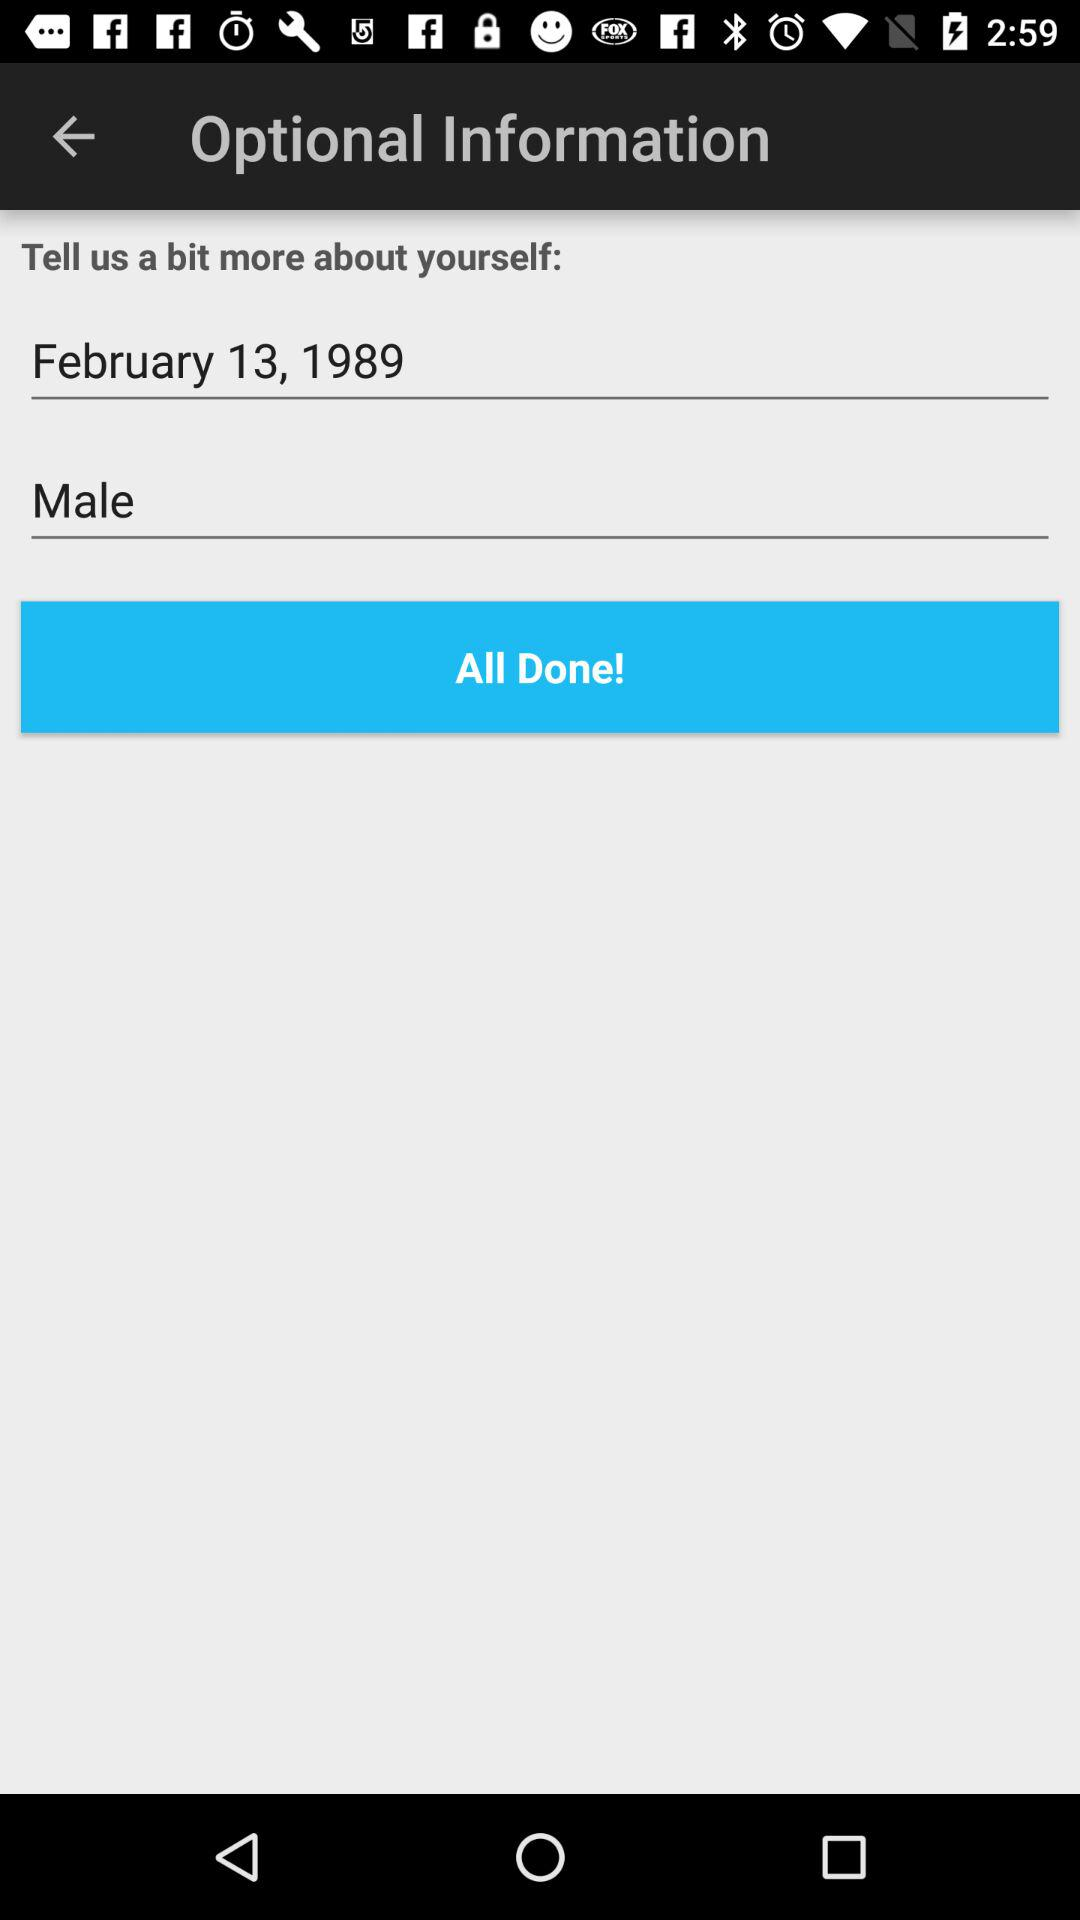What is the given gender? The given gender is male. 